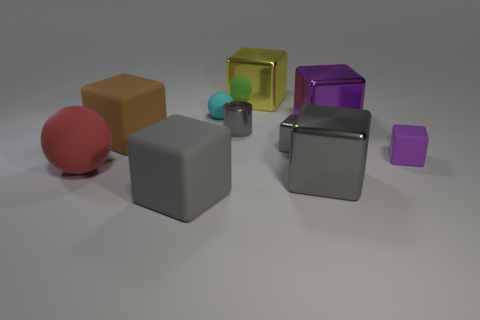There is a big matte cube that is behind the gray rubber object; what color is it?
Offer a terse response. Brown. There is a yellow shiny thing that is the same size as the purple metallic block; what is its shape?
Your response must be concise. Cube. There is a metallic cylinder; is it the same color as the thing right of the big purple thing?
Your answer should be compact. No. How many objects are either cubes right of the gray rubber cube or big objects behind the small cyan matte object?
Offer a very short reply. 5. There is a gray thing that is the same size as the metal cylinder; what is its material?
Provide a succinct answer. Metal. What number of other objects are there of the same material as the large ball?
Your response must be concise. 4. There is a thing that is behind the small cyan thing; is its shape the same as the gray object behind the brown matte cube?
Keep it short and to the point. No. The large cube that is left of the big gray cube to the left of the large metal cube that is in front of the big purple cube is what color?
Provide a short and direct response. Brown. What number of other objects are the same color as the tiny rubber cube?
Provide a succinct answer. 1. Are there fewer small purple blocks than gray things?
Keep it short and to the point. Yes. 